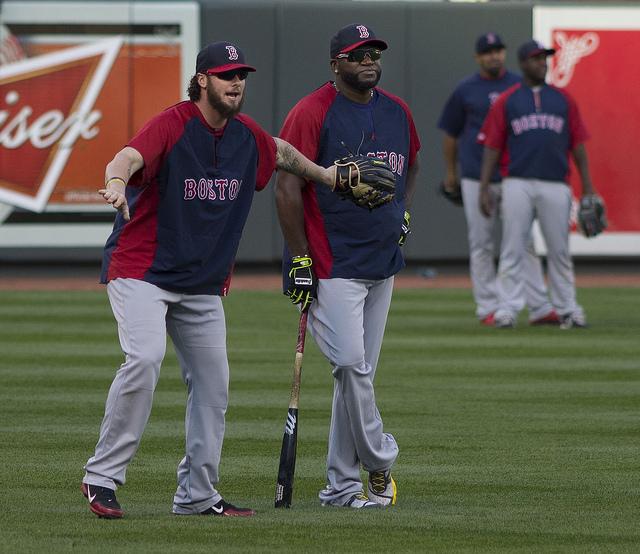Are these players are in the same team?
Short answer required. Yes. Do you see an umbrella?
Answer briefly. No. Is there a ball in this photo?
Short answer required. No. Do all of the people in the picture have on the same uniforms?
Concise answer only. Yes. What game are they playing?
Answer briefly. Baseball. What does the red sign say?
Write a very short answer. Budweiser. How many teams are pictured in this photo?
Be succinct. 1. What sport are the men playing on the field?
Quick response, please. Baseball. What number Jersey is the player furthest to the right wearing?
Give a very brief answer. Unknown. What is the city where this team is from?
Answer briefly. Boston. What team is this?
Keep it brief. Boston. What is this person doing?
Be succinct. Playing baseball. Where is the soccer ball?
Short answer required. Nowhere. Are the men happy?
Quick response, please. No. How many boys in the team?
Be succinct. 4. Is this a professional team?
Keep it brief. Yes. What is the man wearing?
Quick response, please. Uniform. 